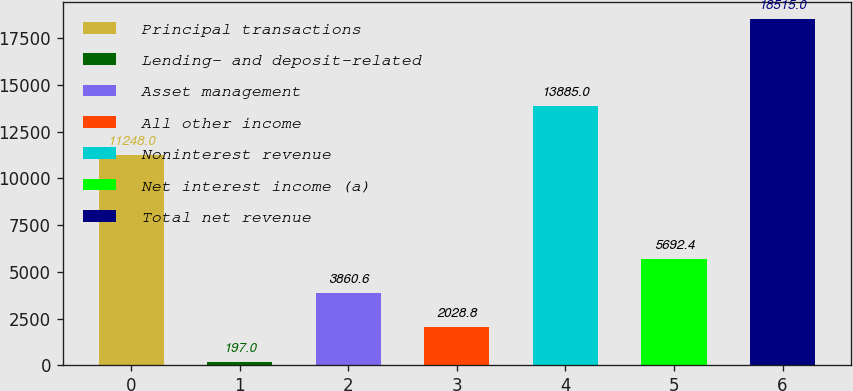Convert chart. <chart><loc_0><loc_0><loc_500><loc_500><bar_chart><fcel>Principal transactions<fcel>Lending- and deposit-related<fcel>Asset management<fcel>All other income<fcel>Noninterest revenue<fcel>Net interest income (a)<fcel>Total net revenue<nl><fcel>11248<fcel>197<fcel>3860.6<fcel>2028.8<fcel>13885<fcel>5692.4<fcel>18515<nl></chart> 